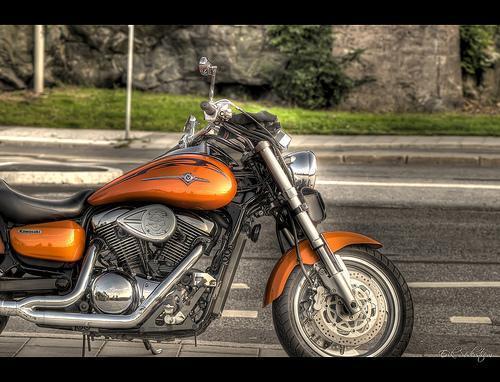How many motorcycles are in this picture?
Give a very brief answer. 1. How many wheels are shown?
Give a very brief answer. 1. How many vehicles are shown?
Give a very brief answer. 1. How many headlights are shown?
Give a very brief answer. 1. 